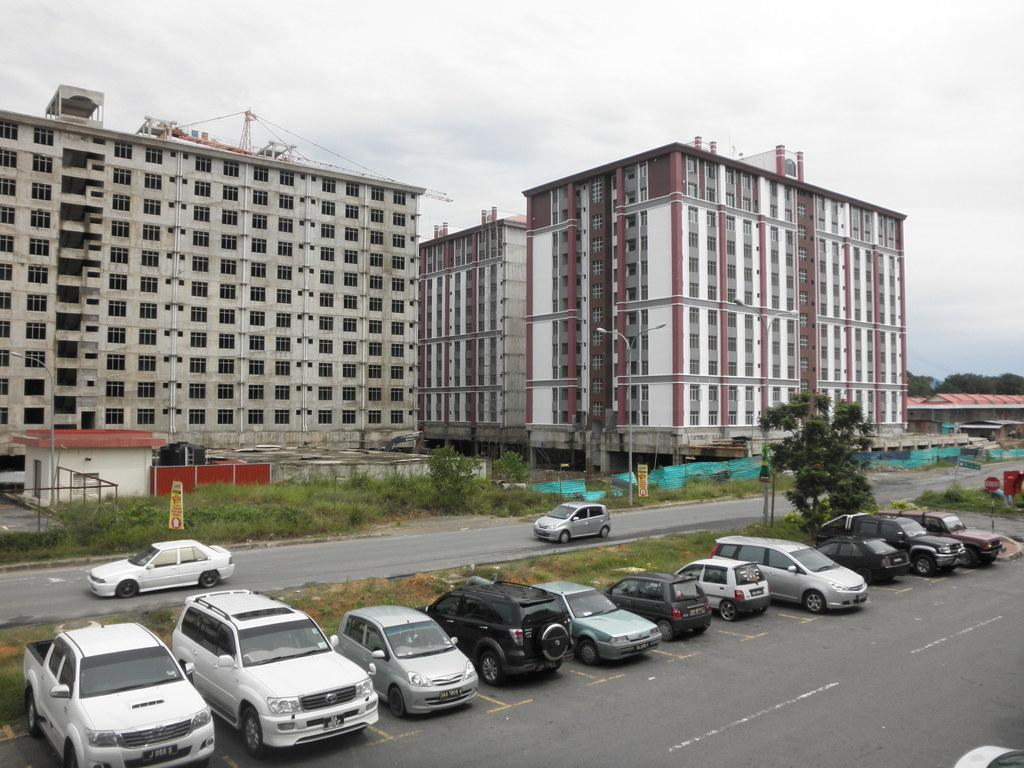What type of structures can be seen in the image? There are buildings in the image. What other natural elements are present in the image? There are trees in the image. What mode of transportation can be seen on the road at the bottom of the image? There are cars on the road at the bottom of the image. What objects are visible with writing or information on them? There are boards visible in the image. What is visible in the background of the image? The sky is visible in the background of the image. What appliance is being used to cook food in the image? There is no appliance visible in the image, as it primarily features buildings, trees, cars, boards, and the sky. 